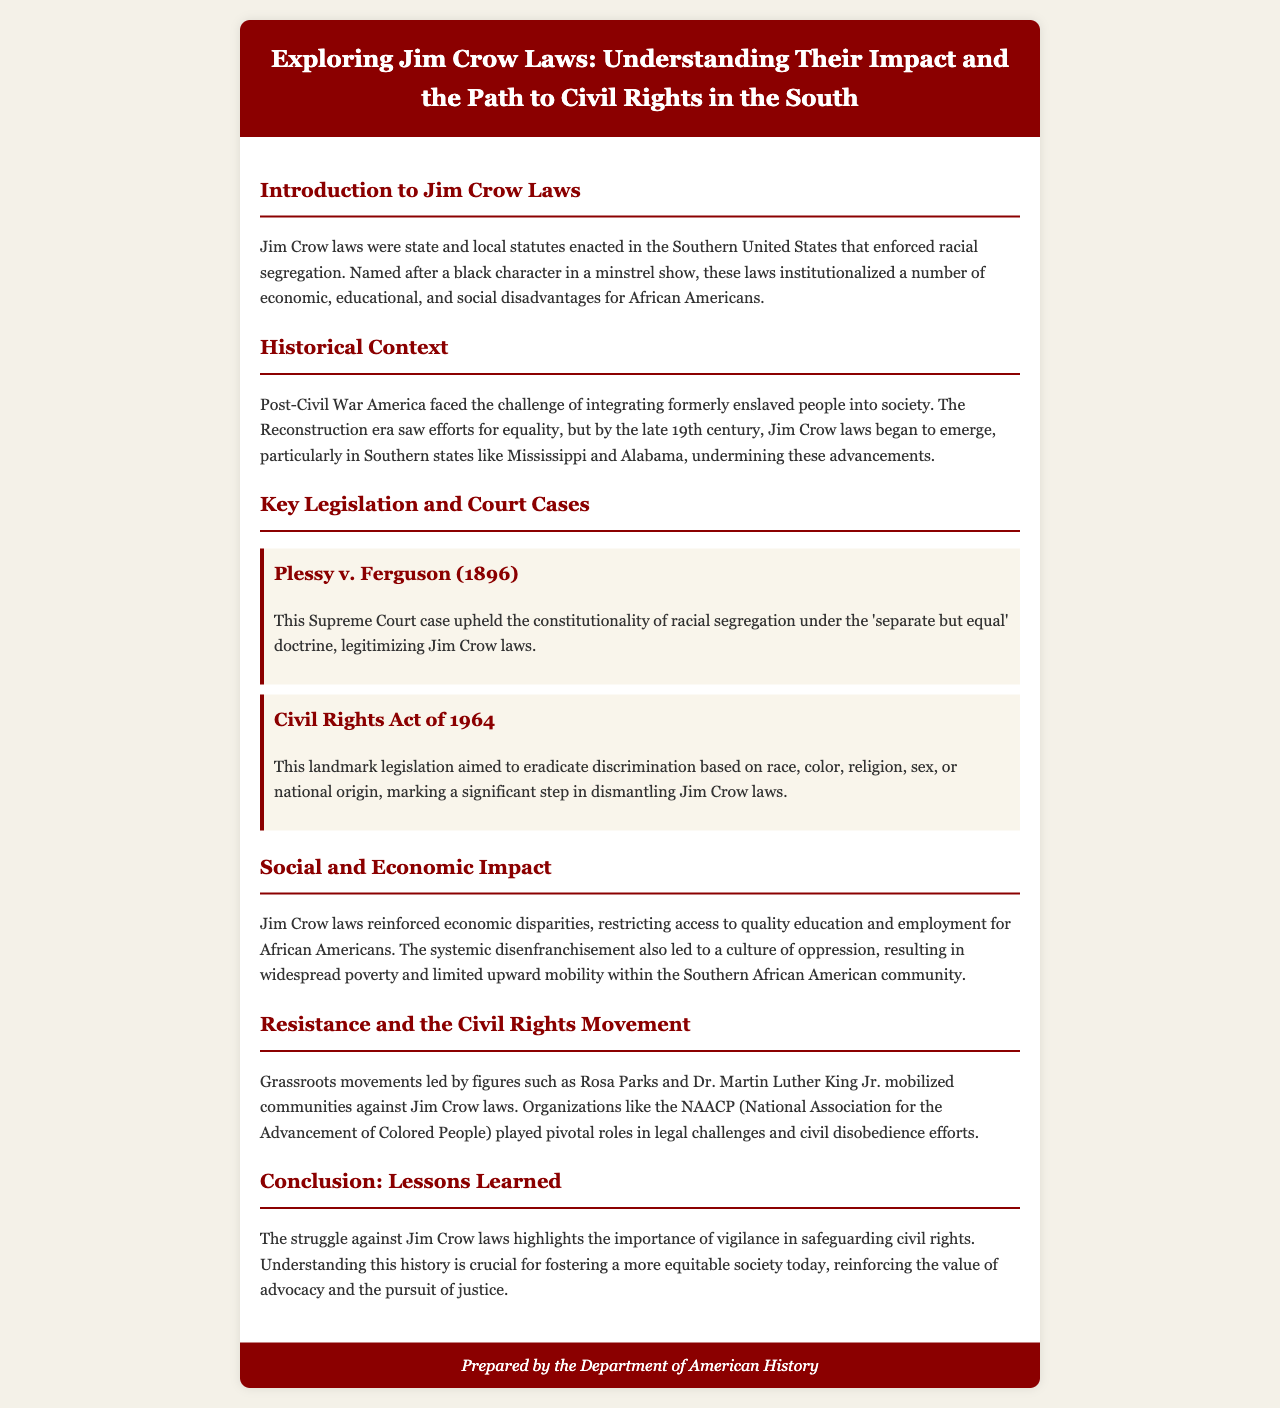What are Jim Crow laws? The document defines Jim Crow laws as state and local statutes enacted in the Southern United States that enforced racial segregation.
Answer: Racial segregation What landmark case upheld Jim Crow laws? The document states that Plessy v. Ferguson (1896) upheld the constitutionality of racial segregation.
Answer: Plessy v. Ferguson What year was the Civil Rights Act passed? The brochure discusses the Civil Rights Act of 1964 as landmark legislation.
Answer: 1964 Who were two prominent figures in the Civil Rights Movement mentioned? The document references Rosa Parks and Dr. Martin Luther King Jr. as significant figures in the movement.
Answer: Rosa Parks and Dr. Martin Luther King Jr What was the primary impact of Jim Crow laws on education? The brochure explains that Jim Crow laws restricted access to quality education for African Americans.
Answer: Restricted access What doctrine was legitimized by the Supreme Court's decision in Plessy v. Ferguson? The document indicates that the 'separate but equal' doctrine was legitimized by this Supreme Court case.
Answer: Separate but equal What organization is noted for its role in legal challenges against Jim Crow? The brochure mentions the NAACP (National Association for the Advancement of Colored People) as playing a pivotal role.
Answer: NAACP What is a key lesson learned from the struggle against Jim Crow laws? The conclusion emphasizes the importance of vigilance in safeguarding civil rights as a key lesson learned.
Answer: Vigilance in safeguarding civil rights 